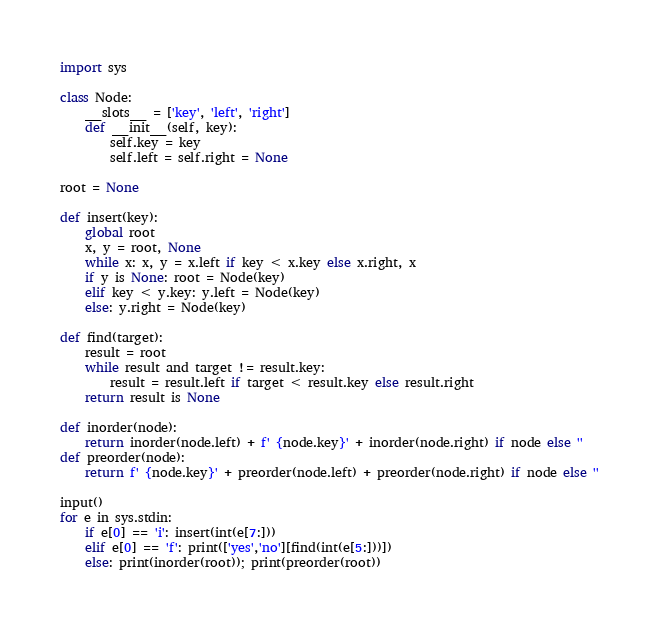Convert code to text. <code><loc_0><loc_0><loc_500><loc_500><_Python_>import sys

class Node:
    __slots__ = ['key', 'left', 'right']
    def __init__(self, key):
        self.key = key
        self.left = self.right = None

root = None

def insert(key):
    global root
    x, y = root, None
    while x: x, y = x.left if key < x.key else x.right, x
    if y is None: root = Node(key)
    elif key < y.key: y.left = Node(key)
    else: y.right = Node(key)

def find(target):
    result = root
    while result and target != result.key:
        result = result.left if target < result.key else result.right
    return result is None

def inorder(node):
    return inorder(node.left) + f' {node.key}' + inorder(node.right) if node else ''
def preorder(node):
    return f' {node.key}' + preorder(node.left) + preorder(node.right) if node else ''

input()
for e in sys.stdin:
    if e[0] == 'i': insert(int(e[7:]))
    elif e[0] == 'f': print(['yes','no'][find(int(e[5:]))])
    else: print(inorder(root)); print(preorder(root))

</code> 